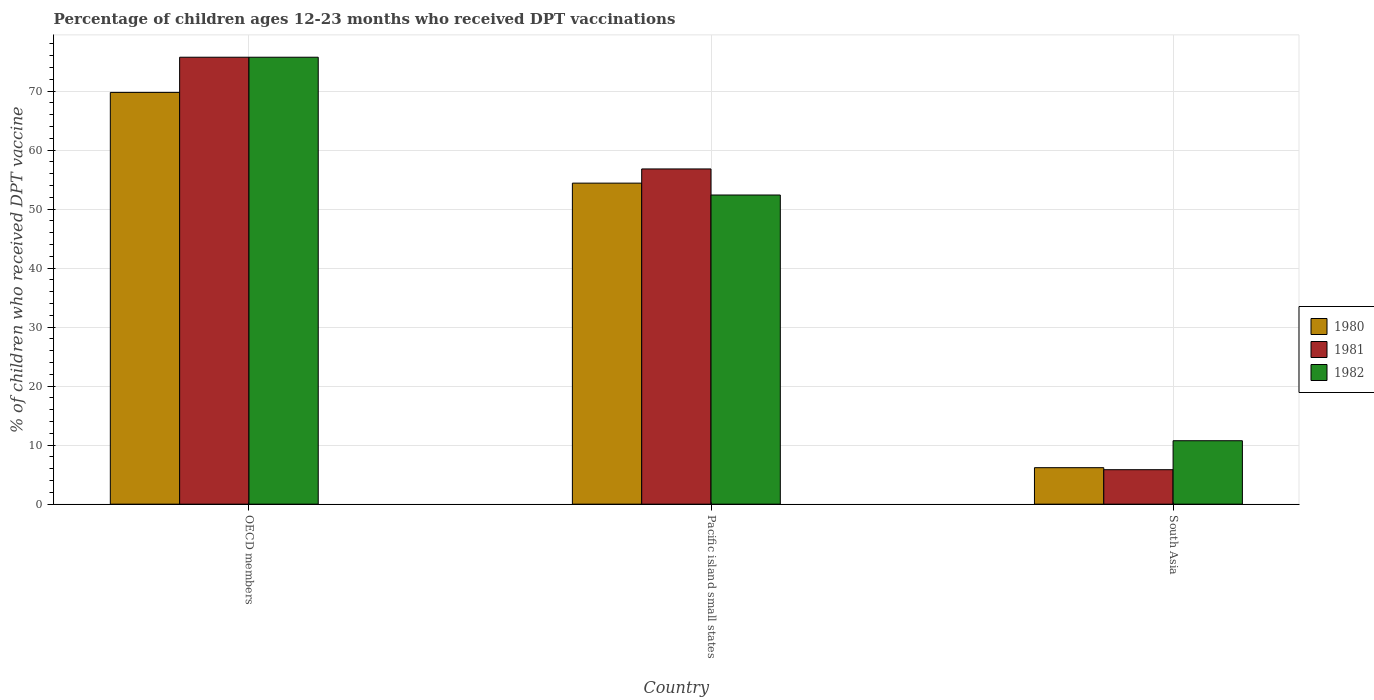How many different coloured bars are there?
Your answer should be compact. 3. Are the number of bars on each tick of the X-axis equal?
Make the answer very short. Yes. How many bars are there on the 1st tick from the right?
Your answer should be compact. 3. What is the percentage of children who received DPT vaccination in 1982 in South Asia?
Give a very brief answer. 10.75. Across all countries, what is the maximum percentage of children who received DPT vaccination in 1980?
Keep it short and to the point. 69.79. Across all countries, what is the minimum percentage of children who received DPT vaccination in 1980?
Offer a terse response. 6.18. In which country was the percentage of children who received DPT vaccination in 1981 maximum?
Your answer should be very brief. OECD members. In which country was the percentage of children who received DPT vaccination in 1982 minimum?
Provide a short and direct response. South Asia. What is the total percentage of children who received DPT vaccination in 1981 in the graph?
Provide a succinct answer. 138.4. What is the difference between the percentage of children who received DPT vaccination in 1981 in Pacific island small states and that in South Asia?
Ensure brevity in your answer.  50.97. What is the difference between the percentage of children who received DPT vaccination in 1982 in Pacific island small states and the percentage of children who received DPT vaccination in 1980 in OECD members?
Give a very brief answer. -17.39. What is the average percentage of children who received DPT vaccination in 1980 per country?
Give a very brief answer. 43.46. What is the difference between the percentage of children who received DPT vaccination of/in 1981 and percentage of children who received DPT vaccination of/in 1982 in Pacific island small states?
Your response must be concise. 4.42. What is the ratio of the percentage of children who received DPT vaccination in 1982 in OECD members to that in South Asia?
Your answer should be compact. 7.04. What is the difference between the highest and the second highest percentage of children who received DPT vaccination in 1982?
Your answer should be very brief. -65. What is the difference between the highest and the lowest percentage of children who received DPT vaccination in 1982?
Your response must be concise. 65. In how many countries, is the percentage of children who received DPT vaccination in 1982 greater than the average percentage of children who received DPT vaccination in 1982 taken over all countries?
Offer a very short reply. 2. Is the sum of the percentage of children who received DPT vaccination in 1980 in OECD members and South Asia greater than the maximum percentage of children who received DPT vaccination in 1982 across all countries?
Your answer should be compact. Yes. What does the 1st bar from the right in Pacific island small states represents?
Keep it short and to the point. 1982. Is it the case that in every country, the sum of the percentage of children who received DPT vaccination in 1981 and percentage of children who received DPT vaccination in 1982 is greater than the percentage of children who received DPT vaccination in 1980?
Ensure brevity in your answer.  Yes. How many bars are there?
Provide a short and direct response. 9. Are all the bars in the graph horizontal?
Provide a succinct answer. No. How many countries are there in the graph?
Give a very brief answer. 3. What is the difference between two consecutive major ticks on the Y-axis?
Offer a terse response. 10. Does the graph contain any zero values?
Provide a succinct answer. No. What is the title of the graph?
Ensure brevity in your answer.  Percentage of children ages 12-23 months who received DPT vaccinations. Does "2014" appear as one of the legend labels in the graph?
Your answer should be compact. No. What is the label or title of the X-axis?
Make the answer very short. Country. What is the label or title of the Y-axis?
Your answer should be very brief. % of children who received DPT vaccine. What is the % of children who received DPT vaccine of 1980 in OECD members?
Provide a short and direct response. 69.79. What is the % of children who received DPT vaccine in 1981 in OECD members?
Your answer should be very brief. 75.75. What is the % of children who received DPT vaccine in 1982 in OECD members?
Your answer should be compact. 75.75. What is the % of children who received DPT vaccine in 1980 in Pacific island small states?
Give a very brief answer. 54.41. What is the % of children who received DPT vaccine in 1981 in Pacific island small states?
Your answer should be very brief. 56.81. What is the % of children who received DPT vaccine of 1982 in Pacific island small states?
Your answer should be compact. 52.4. What is the % of children who received DPT vaccine in 1980 in South Asia?
Offer a very short reply. 6.18. What is the % of children who received DPT vaccine in 1981 in South Asia?
Your answer should be compact. 5.84. What is the % of children who received DPT vaccine of 1982 in South Asia?
Offer a very short reply. 10.75. Across all countries, what is the maximum % of children who received DPT vaccine of 1980?
Provide a succinct answer. 69.79. Across all countries, what is the maximum % of children who received DPT vaccine of 1981?
Make the answer very short. 75.75. Across all countries, what is the maximum % of children who received DPT vaccine in 1982?
Give a very brief answer. 75.75. Across all countries, what is the minimum % of children who received DPT vaccine in 1980?
Keep it short and to the point. 6.18. Across all countries, what is the minimum % of children who received DPT vaccine of 1981?
Ensure brevity in your answer.  5.84. Across all countries, what is the minimum % of children who received DPT vaccine in 1982?
Keep it short and to the point. 10.75. What is the total % of children who received DPT vaccine in 1980 in the graph?
Provide a succinct answer. 130.38. What is the total % of children who received DPT vaccine of 1981 in the graph?
Keep it short and to the point. 138.4. What is the total % of children who received DPT vaccine of 1982 in the graph?
Provide a succinct answer. 138.9. What is the difference between the % of children who received DPT vaccine of 1980 in OECD members and that in Pacific island small states?
Offer a terse response. 15.38. What is the difference between the % of children who received DPT vaccine in 1981 in OECD members and that in Pacific island small states?
Your answer should be very brief. 18.93. What is the difference between the % of children who received DPT vaccine in 1982 in OECD members and that in Pacific island small states?
Your response must be concise. 23.35. What is the difference between the % of children who received DPT vaccine in 1980 in OECD members and that in South Asia?
Give a very brief answer. 63.6. What is the difference between the % of children who received DPT vaccine of 1981 in OECD members and that in South Asia?
Provide a short and direct response. 69.91. What is the difference between the % of children who received DPT vaccine of 1982 in OECD members and that in South Asia?
Ensure brevity in your answer.  65. What is the difference between the % of children who received DPT vaccine in 1980 in Pacific island small states and that in South Asia?
Give a very brief answer. 48.23. What is the difference between the % of children who received DPT vaccine in 1981 in Pacific island small states and that in South Asia?
Provide a succinct answer. 50.97. What is the difference between the % of children who received DPT vaccine of 1982 in Pacific island small states and that in South Asia?
Offer a very short reply. 41.64. What is the difference between the % of children who received DPT vaccine in 1980 in OECD members and the % of children who received DPT vaccine in 1981 in Pacific island small states?
Keep it short and to the point. 12.97. What is the difference between the % of children who received DPT vaccine of 1980 in OECD members and the % of children who received DPT vaccine of 1982 in Pacific island small states?
Your response must be concise. 17.39. What is the difference between the % of children who received DPT vaccine of 1981 in OECD members and the % of children who received DPT vaccine of 1982 in Pacific island small states?
Your answer should be very brief. 23.35. What is the difference between the % of children who received DPT vaccine of 1980 in OECD members and the % of children who received DPT vaccine of 1981 in South Asia?
Make the answer very short. 63.94. What is the difference between the % of children who received DPT vaccine of 1980 in OECD members and the % of children who received DPT vaccine of 1982 in South Asia?
Your answer should be very brief. 59.03. What is the difference between the % of children who received DPT vaccine in 1981 in OECD members and the % of children who received DPT vaccine in 1982 in South Asia?
Make the answer very short. 65. What is the difference between the % of children who received DPT vaccine of 1980 in Pacific island small states and the % of children who received DPT vaccine of 1981 in South Asia?
Ensure brevity in your answer.  48.57. What is the difference between the % of children who received DPT vaccine of 1980 in Pacific island small states and the % of children who received DPT vaccine of 1982 in South Asia?
Your response must be concise. 43.66. What is the difference between the % of children who received DPT vaccine in 1981 in Pacific island small states and the % of children who received DPT vaccine in 1982 in South Asia?
Provide a short and direct response. 46.06. What is the average % of children who received DPT vaccine in 1980 per country?
Your response must be concise. 43.46. What is the average % of children who received DPT vaccine of 1981 per country?
Your answer should be very brief. 46.13. What is the average % of children who received DPT vaccine in 1982 per country?
Give a very brief answer. 46.3. What is the difference between the % of children who received DPT vaccine in 1980 and % of children who received DPT vaccine in 1981 in OECD members?
Make the answer very short. -5.96. What is the difference between the % of children who received DPT vaccine of 1980 and % of children who received DPT vaccine of 1982 in OECD members?
Your response must be concise. -5.96. What is the difference between the % of children who received DPT vaccine in 1981 and % of children who received DPT vaccine in 1982 in OECD members?
Offer a very short reply. -0. What is the difference between the % of children who received DPT vaccine in 1980 and % of children who received DPT vaccine in 1981 in Pacific island small states?
Provide a succinct answer. -2.41. What is the difference between the % of children who received DPT vaccine of 1980 and % of children who received DPT vaccine of 1982 in Pacific island small states?
Give a very brief answer. 2.01. What is the difference between the % of children who received DPT vaccine in 1981 and % of children who received DPT vaccine in 1982 in Pacific island small states?
Your answer should be compact. 4.42. What is the difference between the % of children who received DPT vaccine in 1980 and % of children who received DPT vaccine in 1981 in South Asia?
Provide a succinct answer. 0.34. What is the difference between the % of children who received DPT vaccine of 1980 and % of children who received DPT vaccine of 1982 in South Asia?
Ensure brevity in your answer.  -4.57. What is the difference between the % of children who received DPT vaccine of 1981 and % of children who received DPT vaccine of 1982 in South Asia?
Provide a short and direct response. -4.91. What is the ratio of the % of children who received DPT vaccine in 1980 in OECD members to that in Pacific island small states?
Make the answer very short. 1.28. What is the ratio of the % of children who received DPT vaccine of 1982 in OECD members to that in Pacific island small states?
Provide a short and direct response. 1.45. What is the ratio of the % of children who received DPT vaccine of 1980 in OECD members to that in South Asia?
Provide a succinct answer. 11.29. What is the ratio of the % of children who received DPT vaccine in 1981 in OECD members to that in South Asia?
Ensure brevity in your answer.  12.97. What is the ratio of the % of children who received DPT vaccine in 1982 in OECD members to that in South Asia?
Provide a short and direct response. 7.04. What is the ratio of the % of children who received DPT vaccine in 1980 in Pacific island small states to that in South Asia?
Your response must be concise. 8.8. What is the ratio of the % of children who received DPT vaccine of 1981 in Pacific island small states to that in South Asia?
Offer a very short reply. 9.73. What is the ratio of the % of children who received DPT vaccine in 1982 in Pacific island small states to that in South Asia?
Give a very brief answer. 4.87. What is the difference between the highest and the second highest % of children who received DPT vaccine of 1980?
Offer a very short reply. 15.38. What is the difference between the highest and the second highest % of children who received DPT vaccine in 1981?
Keep it short and to the point. 18.93. What is the difference between the highest and the second highest % of children who received DPT vaccine in 1982?
Provide a succinct answer. 23.35. What is the difference between the highest and the lowest % of children who received DPT vaccine in 1980?
Make the answer very short. 63.6. What is the difference between the highest and the lowest % of children who received DPT vaccine of 1981?
Offer a terse response. 69.91. What is the difference between the highest and the lowest % of children who received DPT vaccine of 1982?
Provide a succinct answer. 65. 